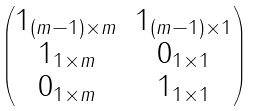Convert formula to latex. <formula><loc_0><loc_0><loc_500><loc_500>\begin{pmatrix} 1 _ { ( m - 1 ) \times m } & 1 _ { ( m - 1 ) \times 1 } \\ 1 _ { 1 \times m } & 0 _ { 1 \times 1 } \\ 0 _ { 1 \times m } & 1 _ { 1 \times 1 } \end{pmatrix}</formula> 